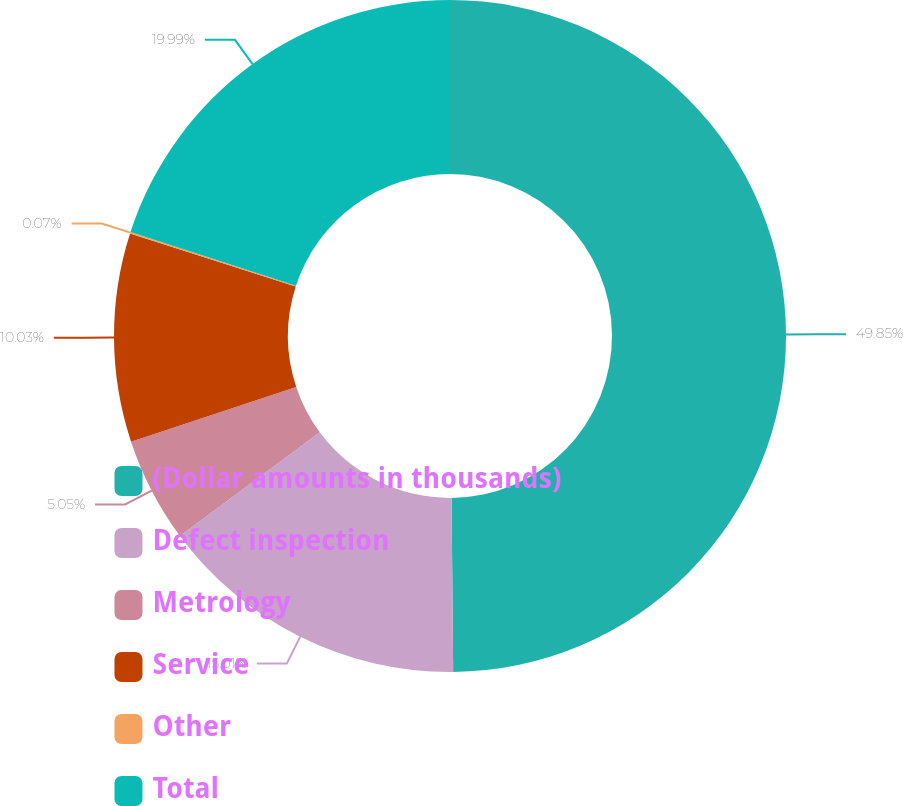Convert chart to OTSL. <chart><loc_0><loc_0><loc_500><loc_500><pie_chart><fcel>(Dollar amounts in thousands)<fcel>Defect inspection<fcel>Metrology<fcel>Service<fcel>Other<fcel>Total<nl><fcel>49.85%<fcel>15.01%<fcel>5.05%<fcel>10.03%<fcel>0.07%<fcel>19.99%<nl></chart> 